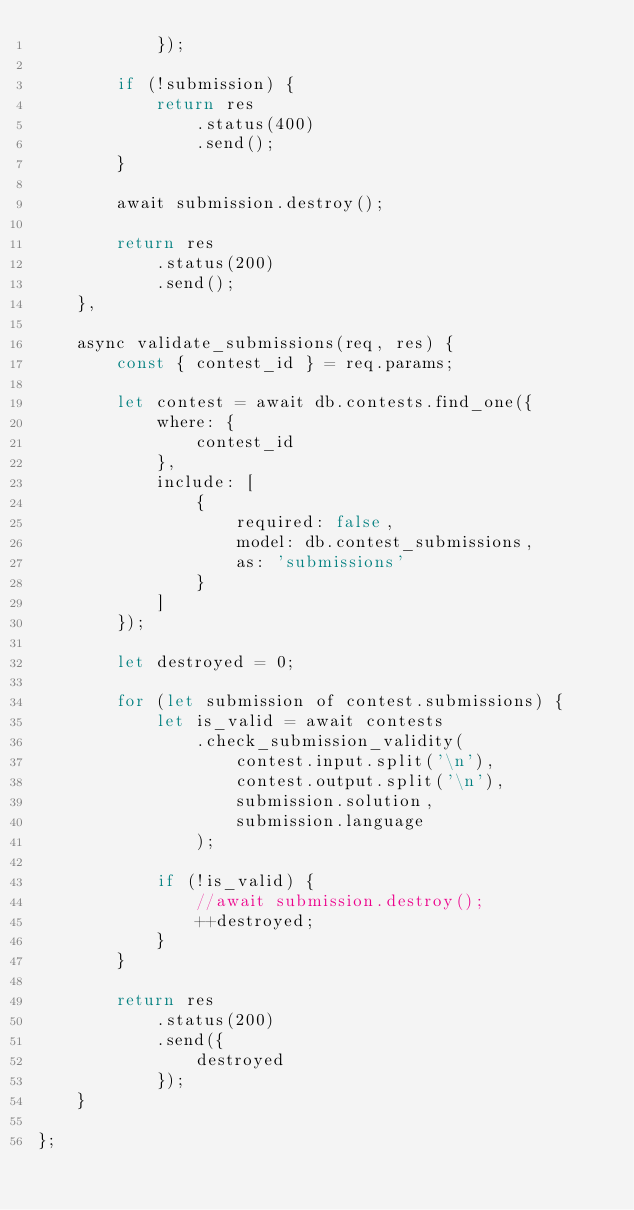<code> <loc_0><loc_0><loc_500><loc_500><_JavaScript_>            });

        if (!submission) {
            return res
                .status(400)
                .send();
        }

        await submission.destroy();

        return res
            .status(200)
            .send();
    },

    async validate_submissions(req, res) {
        const { contest_id } = req.params;

        let contest = await db.contests.find_one({
            where: {
                contest_id
            },
            include: [
                {
                    required: false,
                    model: db.contest_submissions,
                    as: 'submissions'
                }
            ]
        });

        let destroyed = 0;

        for (let submission of contest.submissions) {
            let is_valid = await contests
                .check_submission_validity(
                    contest.input.split('\n'),
                    contest.output.split('\n'),
                    submission.solution,
                    submission.language
                );

            if (!is_valid) {
                //await submission.destroy();
                ++destroyed;
            }
        }

        return res
            .status(200)
            .send({
                destroyed
            });
    }

};
</code> 